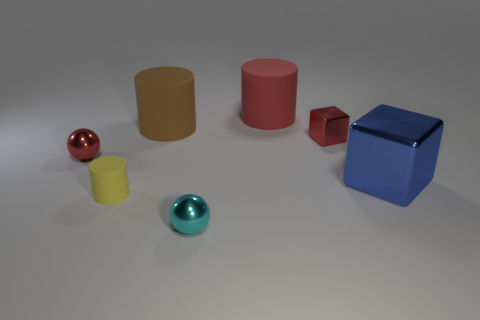Add 2 big cyan shiny cylinders. How many objects exist? 9 Subtract all cylinders. How many objects are left? 4 Subtract all tiny rubber objects. Subtract all big blue metal blocks. How many objects are left? 5 Add 1 cyan spheres. How many cyan spheres are left? 2 Add 4 tiny yellow cylinders. How many tiny yellow cylinders exist? 5 Subtract 0 yellow cubes. How many objects are left? 7 